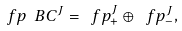Convert formula to latex. <formula><loc_0><loc_0><loc_500><loc_500>\ f p _ { \ } B C ^ { J } = \ f p ^ { J } _ { + } \oplus \ f p ^ { J } _ { - } ,</formula> 